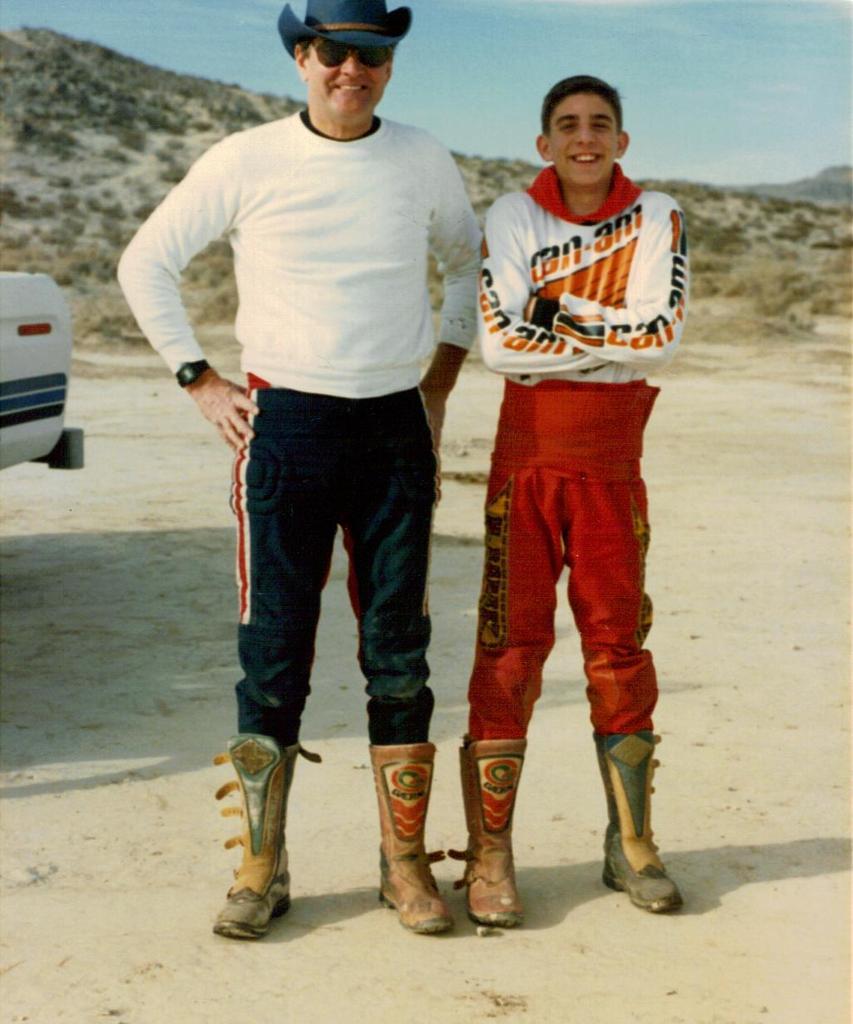What is the brand of the boys shirt?
Provide a succinct answer. Can-am. 